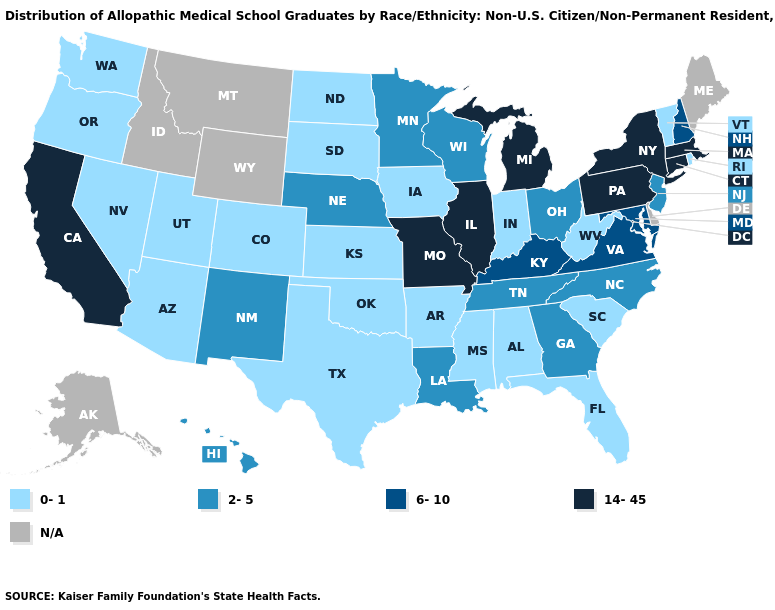Name the states that have a value in the range 0-1?
Keep it brief. Alabama, Arizona, Arkansas, Colorado, Florida, Indiana, Iowa, Kansas, Mississippi, Nevada, North Dakota, Oklahoma, Oregon, Rhode Island, South Carolina, South Dakota, Texas, Utah, Vermont, Washington, West Virginia. Which states have the lowest value in the Northeast?
Short answer required. Rhode Island, Vermont. Does Michigan have the highest value in the USA?
Answer briefly. Yes. Which states have the lowest value in the West?
Concise answer only. Arizona, Colorado, Nevada, Oregon, Utah, Washington. Does New Mexico have the highest value in the West?
Short answer required. No. Does Pennsylvania have the highest value in the Northeast?
Short answer required. Yes. Name the states that have a value in the range 2-5?
Quick response, please. Georgia, Hawaii, Louisiana, Minnesota, Nebraska, New Jersey, New Mexico, North Carolina, Ohio, Tennessee, Wisconsin. Does the first symbol in the legend represent the smallest category?
Write a very short answer. Yes. Does the map have missing data?
Keep it brief. Yes. Does Michigan have the highest value in the MidWest?
Write a very short answer. Yes. Name the states that have a value in the range 6-10?
Give a very brief answer. Kentucky, Maryland, New Hampshire, Virginia. What is the value of North Carolina?
Keep it brief. 2-5. Name the states that have a value in the range 14-45?
Give a very brief answer. California, Connecticut, Illinois, Massachusetts, Michigan, Missouri, New York, Pennsylvania. What is the value of Iowa?
Write a very short answer. 0-1. 